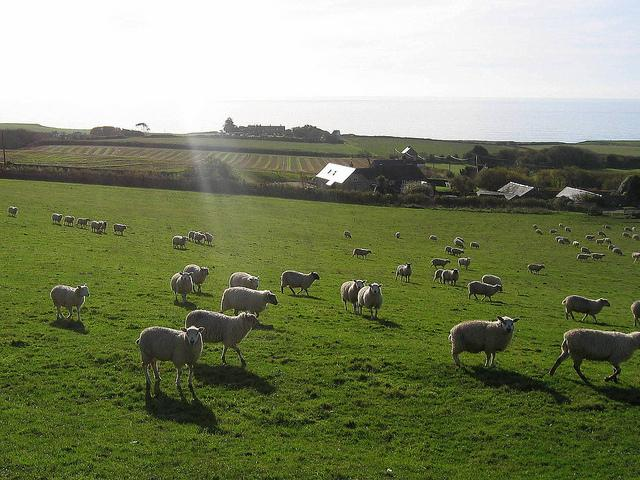What type of worker would be found here?

Choices:
A) farmer
B) dentist
C) judge
D) doctor farmer 